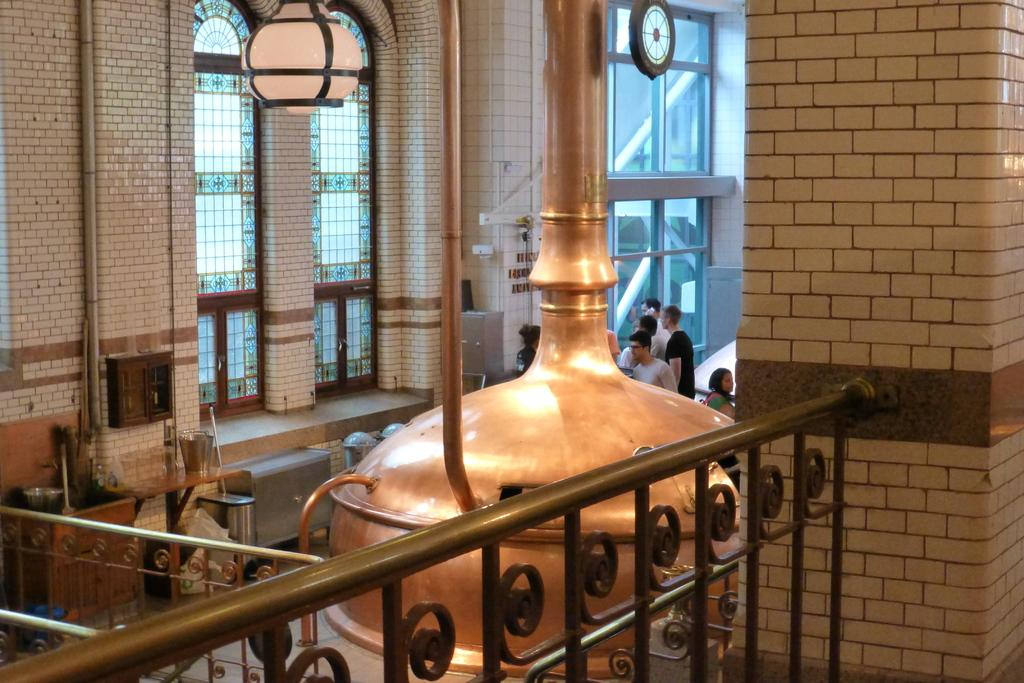What type of barrier can be seen in the image? There is a fence in the image. Who or what is present in the image? There are people in the image. What can be found on the ground in the image? There are objects on the ground in the image. What is visible in the background of the image? There is a framed glass wall and pipes attached to the wall in the background of the image. Are there any other objects visible in the background of the image? Yes, there are other objects visible in the background of the image. Can you tell me how many snakes are slithering around the people in the image? There are no snakes present in the image; it only features a fence, people, objects on the ground, and a framed glass wall with pipes in the background. What type of vein is visible on the people in the image? There is no mention of veins or any medical conditions in the image; it simply shows a fence, people, objects on the ground, and a framed glass wall with pipes in the background. 